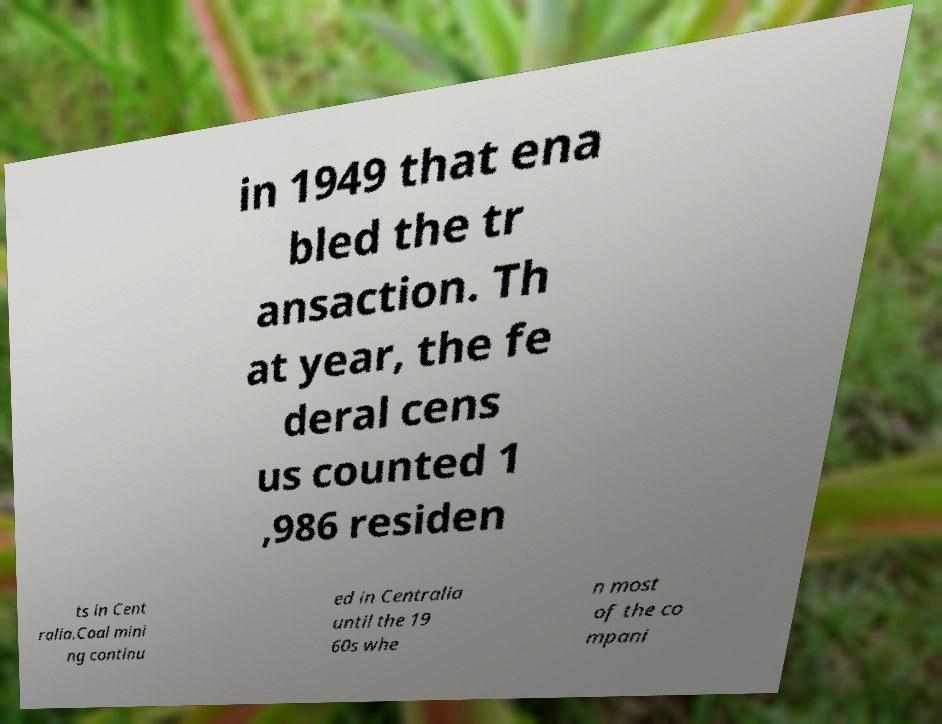Please read and relay the text visible in this image. What does it say? in 1949 that ena bled the tr ansaction. Th at year, the fe deral cens us counted 1 ,986 residen ts in Cent ralia.Coal mini ng continu ed in Centralia until the 19 60s whe n most of the co mpani 